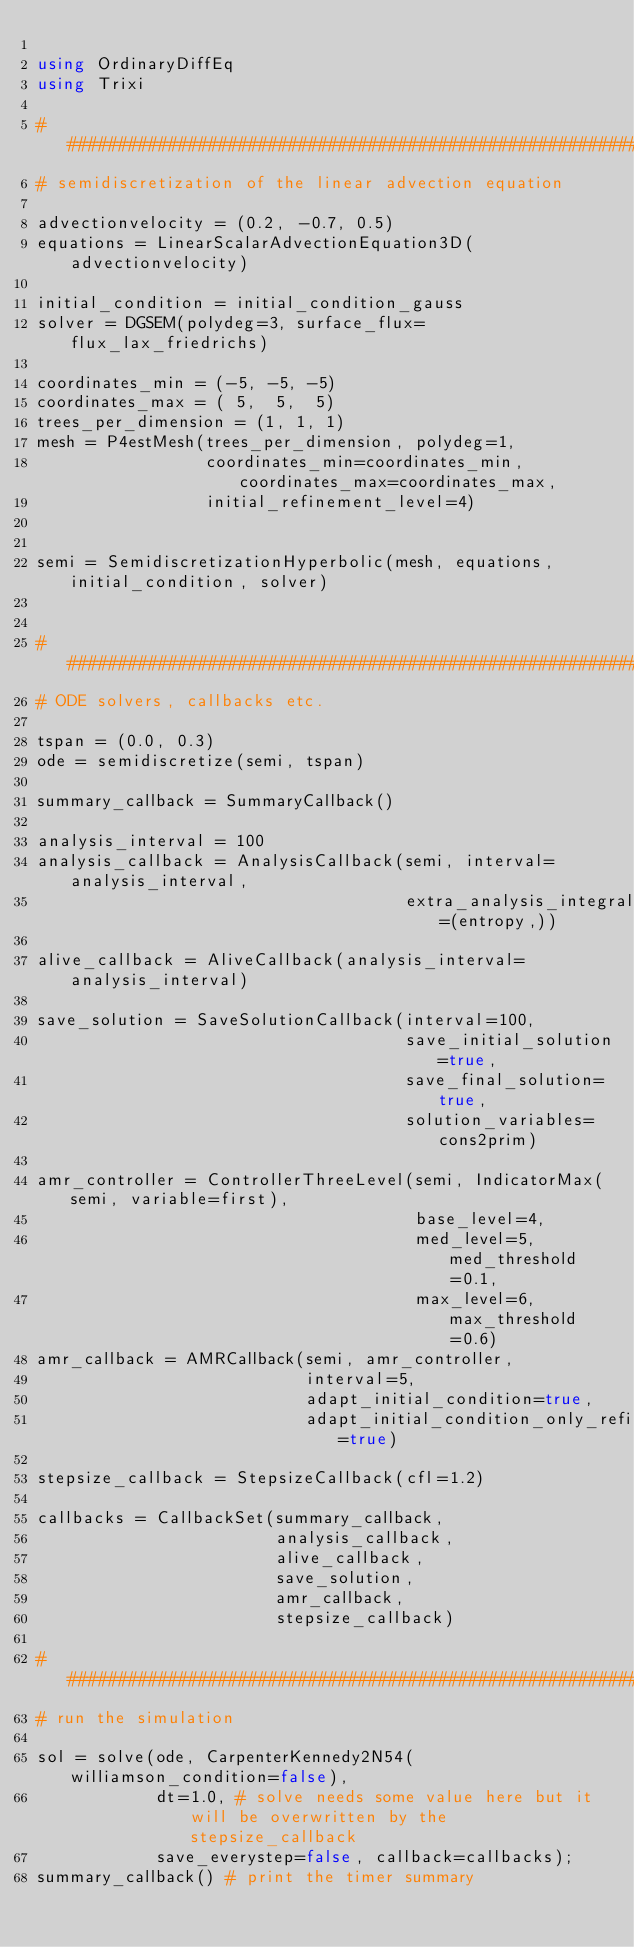Convert code to text. <code><loc_0><loc_0><loc_500><loc_500><_Julia_>
using OrdinaryDiffEq
using Trixi

###############################################################################
# semidiscretization of the linear advection equation

advectionvelocity = (0.2, -0.7, 0.5)
equations = LinearScalarAdvectionEquation3D(advectionvelocity)

initial_condition = initial_condition_gauss
solver = DGSEM(polydeg=3, surface_flux=flux_lax_friedrichs)

coordinates_min = (-5, -5, -5)
coordinates_max = ( 5,  5,  5)
trees_per_dimension = (1, 1, 1)
mesh = P4estMesh(trees_per_dimension, polydeg=1,
                 coordinates_min=coordinates_min, coordinates_max=coordinates_max,
                 initial_refinement_level=4)


semi = SemidiscretizationHyperbolic(mesh, equations, initial_condition, solver)


###############################################################################
# ODE solvers, callbacks etc.

tspan = (0.0, 0.3)
ode = semidiscretize(semi, tspan)

summary_callback = SummaryCallback()

analysis_interval = 100
analysis_callback = AnalysisCallback(semi, interval=analysis_interval,
                                     extra_analysis_integrals=(entropy,))

alive_callback = AliveCallback(analysis_interval=analysis_interval)

save_solution = SaveSolutionCallback(interval=100,
                                     save_initial_solution=true,
                                     save_final_solution=true,
                                     solution_variables=cons2prim)

amr_controller = ControllerThreeLevel(semi, IndicatorMax(semi, variable=first),
                                      base_level=4,
                                      med_level=5, med_threshold=0.1,
                                      max_level=6, max_threshold=0.6)
amr_callback = AMRCallback(semi, amr_controller,
                           interval=5,
                           adapt_initial_condition=true,
                           adapt_initial_condition_only_refine=true)

stepsize_callback = StepsizeCallback(cfl=1.2)

callbacks = CallbackSet(summary_callback,
                        analysis_callback,
                        alive_callback,
                        save_solution,
                        amr_callback,
                        stepsize_callback)

###############################################################################
# run the simulation

sol = solve(ode, CarpenterKennedy2N54(williamson_condition=false),
            dt=1.0, # solve needs some value here but it will be overwritten by the stepsize_callback
            save_everystep=false, callback=callbacks);
summary_callback() # print the timer summary
</code> 